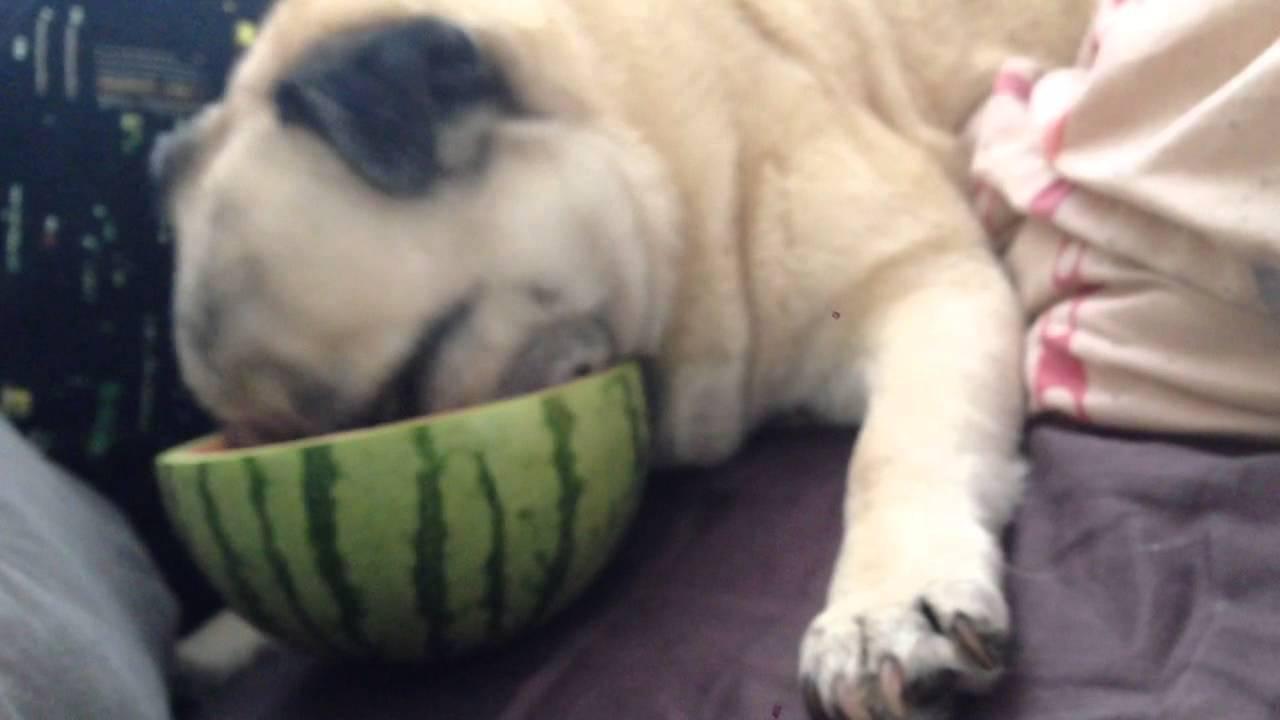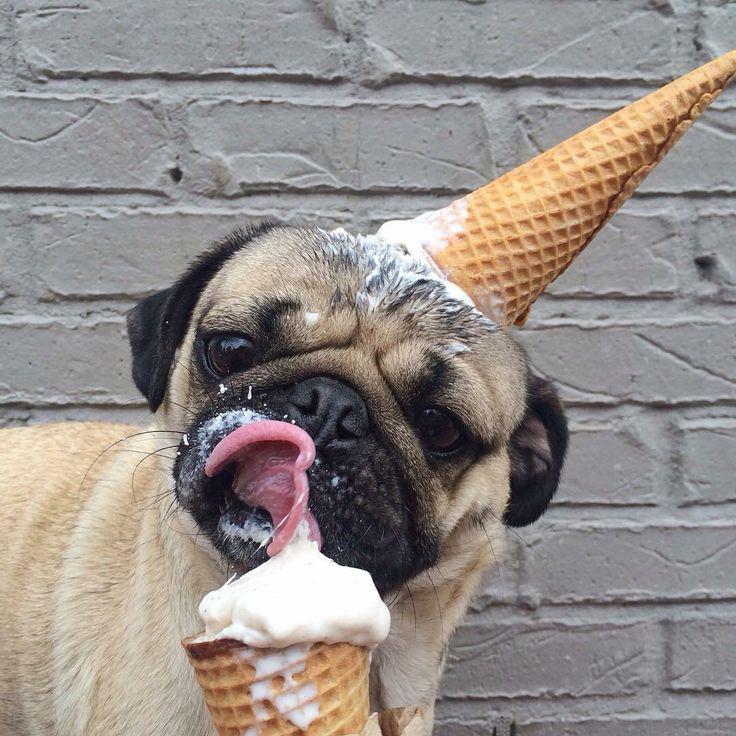The first image is the image on the left, the second image is the image on the right. Considering the images on both sides, is "The dog in the image on the left is eating a chunk of watermelon." valid? Answer yes or no. Yes. The first image is the image on the left, the second image is the image on the right. For the images shown, is this caption "An image shows a pug dog chomping on watermelon." true? Answer yes or no. Yes. 